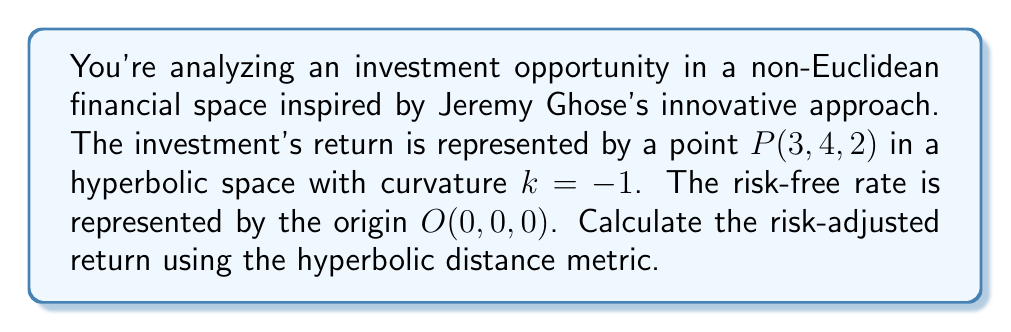Can you answer this question? To solve this problem, we'll follow these steps:

1) In hyperbolic space with curvature $k = -1$, the distance $d$ between two points $(x_1, y_1, z_1)$ and $(x_2, y_2, z_2)$ is given by:

   $$d = \text{arcosh}(1 + \frac{(x_2-x_1)^2 + (y_2-y_1)^2 + (z_2-z_1)^2}{2})$$

   where arcosh is the inverse hyperbolic cosine function.

2) In our case, $(x_1, y_1, z_1) = (0, 0, 0)$ and $(x_2, y_2, z_2) = (3, 4, 2)$. Let's substitute these values:

   $$d = \text{arcosh}(1 + \frac{(3-0)^2 + (4-0)^2 + (2-0)^2}{2})$$

3) Simplify:

   $$d = \text{arcosh}(1 + \frac{9 + 16 + 4}{2}) = \text{arcosh}(1 + \frac{29}{2}) = \text{arcosh}(15.5)$$

4) Calculate:

   $$d \approx 3.0485$$

5) In this non-Euclidean framework, we interpret this hyperbolic distance as the risk-adjusted return. The greater the distance from the risk-free point (origin), the higher the risk-adjusted return.

Therefore, the risk-adjusted return of the investment is approximately 3.0485 or 304.85%.
Answer: 304.85% 